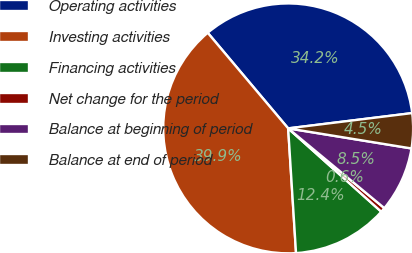Convert chart. <chart><loc_0><loc_0><loc_500><loc_500><pie_chart><fcel>Operating activities<fcel>Investing activities<fcel>Financing activities<fcel>Net change for the period<fcel>Balance at beginning of period<fcel>Balance at end of period<nl><fcel>34.18%<fcel>39.87%<fcel>12.38%<fcel>0.6%<fcel>8.45%<fcel>4.52%<nl></chart> 